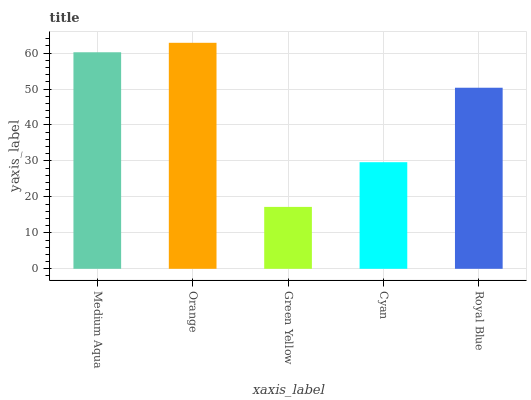Is Green Yellow the minimum?
Answer yes or no. Yes. Is Orange the maximum?
Answer yes or no. Yes. Is Orange the minimum?
Answer yes or no. No. Is Green Yellow the maximum?
Answer yes or no. No. Is Orange greater than Green Yellow?
Answer yes or no. Yes. Is Green Yellow less than Orange?
Answer yes or no. Yes. Is Green Yellow greater than Orange?
Answer yes or no. No. Is Orange less than Green Yellow?
Answer yes or no. No. Is Royal Blue the high median?
Answer yes or no. Yes. Is Royal Blue the low median?
Answer yes or no. Yes. Is Green Yellow the high median?
Answer yes or no. No. Is Green Yellow the low median?
Answer yes or no. No. 